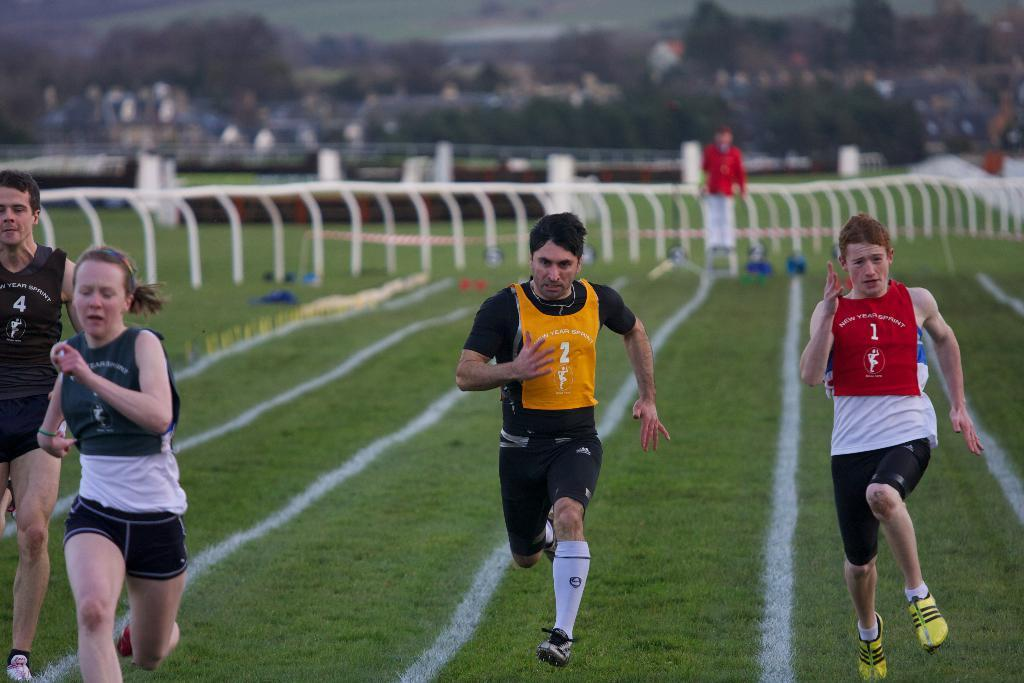What are the people in the image doing? The people in the image are running on the ground. Can you describe the person standing behind the runners? There is a person standing behind the runners in the image. What can be seen in the image to control or direct the flow of people? Barricades are visible in the image. What type of natural scenery is visible in the background of the image? There are trees in the background of the image. How would you describe the quality of the background in the image? The background of the image is blurred. What type of pet can be seen playing with a box in the image? There is no pet or box present in the image; it features people running and barricades. 